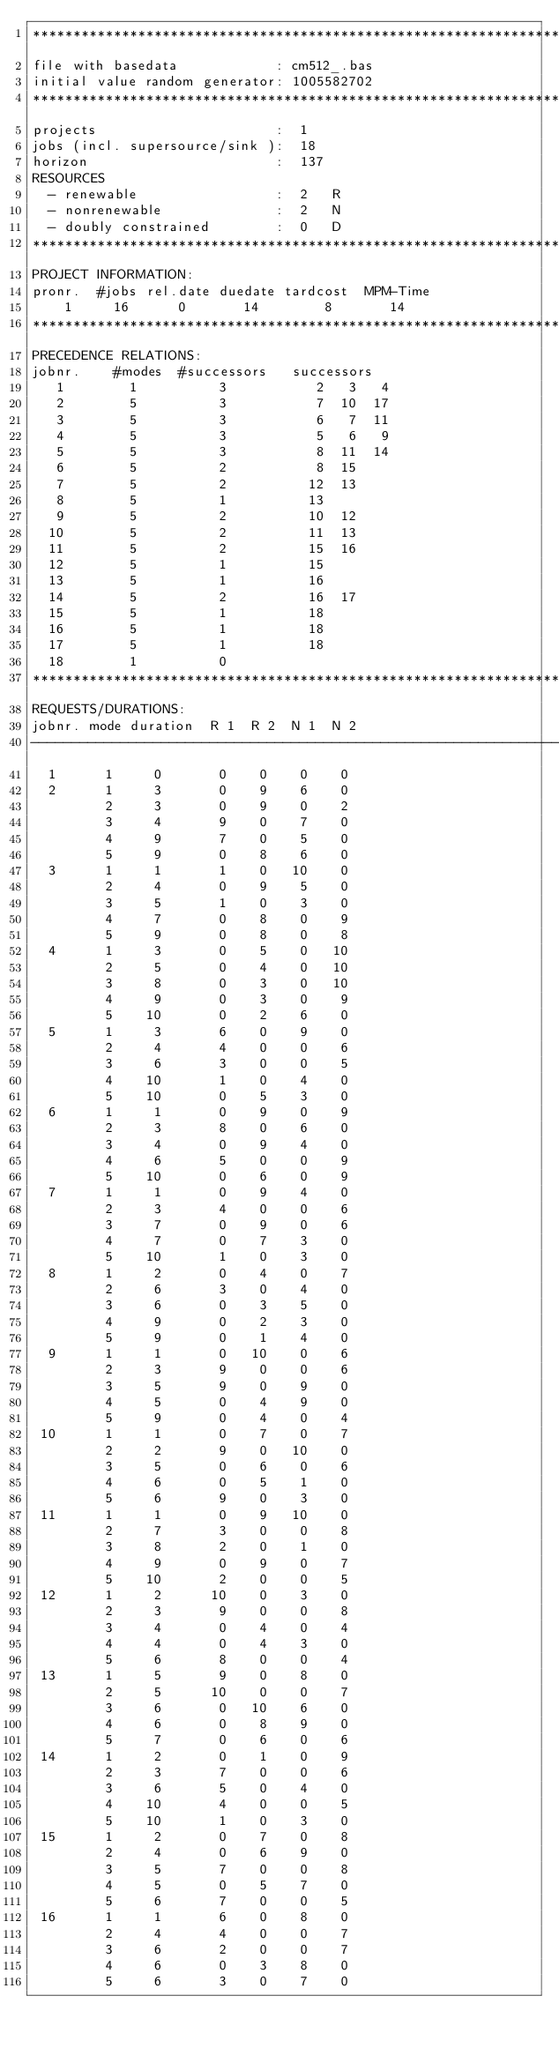Convert code to text. <code><loc_0><loc_0><loc_500><loc_500><_ObjectiveC_>************************************************************************
file with basedata            : cm512_.bas
initial value random generator: 1005582702
************************************************************************
projects                      :  1
jobs (incl. supersource/sink ):  18
horizon                       :  137
RESOURCES
  - renewable                 :  2   R
  - nonrenewable              :  2   N
  - doubly constrained        :  0   D
************************************************************************
PROJECT INFORMATION:
pronr.  #jobs rel.date duedate tardcost  MPM-Time
    1     16      0       14        8       14
************************************************************************
PRECEDENCE RELATIONS:
jobnr.    #modes  #successors   successors
   1        1          3           2   3   4
   2        5          3           7  10  17
   3        5          3           6   7  11
   4        5          3           5   6   9
   5        5          3           8  11  14
   6        5          2           8  15
   7        5          2          12  13
   8        5          1          13
   9        5          2          10  12
  10        5          2          11  13
  11        5          2          15  16
  12        5          1          15
  13        5          1          16
  14        5          2          16  17
  15        5          1          18
  16        5          1          18
  17        5          1          18
  18        1          0        
************************************************************************
REQUESTS/DURATIONS:
jobnr. mode duration  R 1  R 2  N 1  N 2
------------------------------------------------------------------------
  1      1     0       0    0    0    0
  2      1     3       0    9    6    0
         2     3       0    9    0    2
         3     4       9    0    7    0
         4     9       7    0    5    0
         5     9       0    8    6    0
  3      1     1       1    0   10    0
         2     4       0    9    5    0
         3     5       1    0    3    0
         4     7       0    8    0    9
         5     9       0    8    0    8
  4      1     3       0    5    0   10
         2     5       0    4    0   10
         3     8       0    3    0   10
         4     9       0    3    0    9
         5    10       0    2    6    0
  5      1     3       6    0    9    0
         2     4       4    0    0    6
         3     6       3    0    0    5
         4    10       1    0    4    0
         5    10       0    5    3    0
  6      1     1       0    9    0    9
         2     3       8    0    6    0
         3     4       0    9    4    0
         4     6       5    0    0    9
         5    10       0    6    0    9
  7      1     1       0    9    4    0
         2     3       4    0    0    6
         3     7       0    9    0    6
         4     7       0    7    3    0
         5    10       1    0    3    0
  8      1     2       0    4    0    7
         2     6       3    0    4    0
         3     6       0    3    5    0
         4     9       0    2    3    0
         5     9       0    1    4    0
  9      1     1       0   10    0    6
         2     3       9    0    0    6
         3     5       9    0    9    0
         4     5       0    4    9    0
         5     9       0    4    0    4
 10      1     1       0    7    0    7
         2     2       9    0   10    0
         3     5       0    6    0    6
         4     6       0    5    1    0
         5     6       9    0    3    0
 11      1     1       0    9   10    0
         2     7       3    0    0    8
         3     8       2    0    1    0
         4     9       0    9    0    7
         5    10       2    0    0    5
 12      1     2      10    0    3    0
         2     3       9    0    0    8
         3     4       0    4    0    4
         4     4       0    4    3    0
         5     6       8    0    0    4
 13      1     5       9    0    8    0
         2     5      10    0    0    7
         3     6       0   10    6    0
         4     6       0    8    9    0
         5     7       0    6    0    6
 14      1     2       0    1    0    9
         2     3       7    0    0    6
         3     6       5    0    4    0
         4    10       4    0    0    5
         5    10       1    0    3    0
 15      1     2       0    7    0    8
         2     4       0    6    9    0
         3     5       7    0    0    8
         4     5       0    5    7    0
         5     6       7    0    0    5
 16      1     1       6    0    8    0
         2     4       4    0    0    7
         3     6       2    0    0    7
         4     6       0    3    8    0
         5     6       3    0    7    0</code> 